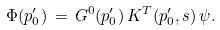<formula> <loc_0><loc_0><loc_500><loc_500>\Phi ( p ^ { \prime } _ { 0 } ) \, = \, G ^ { 0 } ( p ^ { \prime } _ { 0 } ) \, K ^ { T } ( p ^ { \prime } _ { 0 } , s ) \, \psi .</formula> 